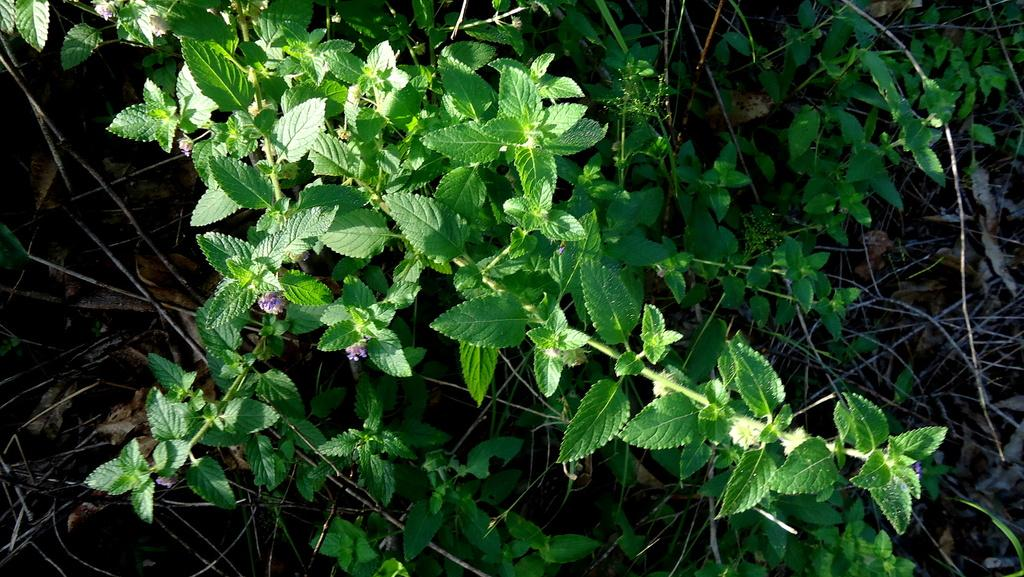What type of living organisms can be seen in the image? Plants can be seen in the image. What specific feature of the plants is visible in the image? The plants have flowers. What type of noise can be heard coming from the plants in the image? There is no noise coming from the plants in the image, as plants do not produce sound. 